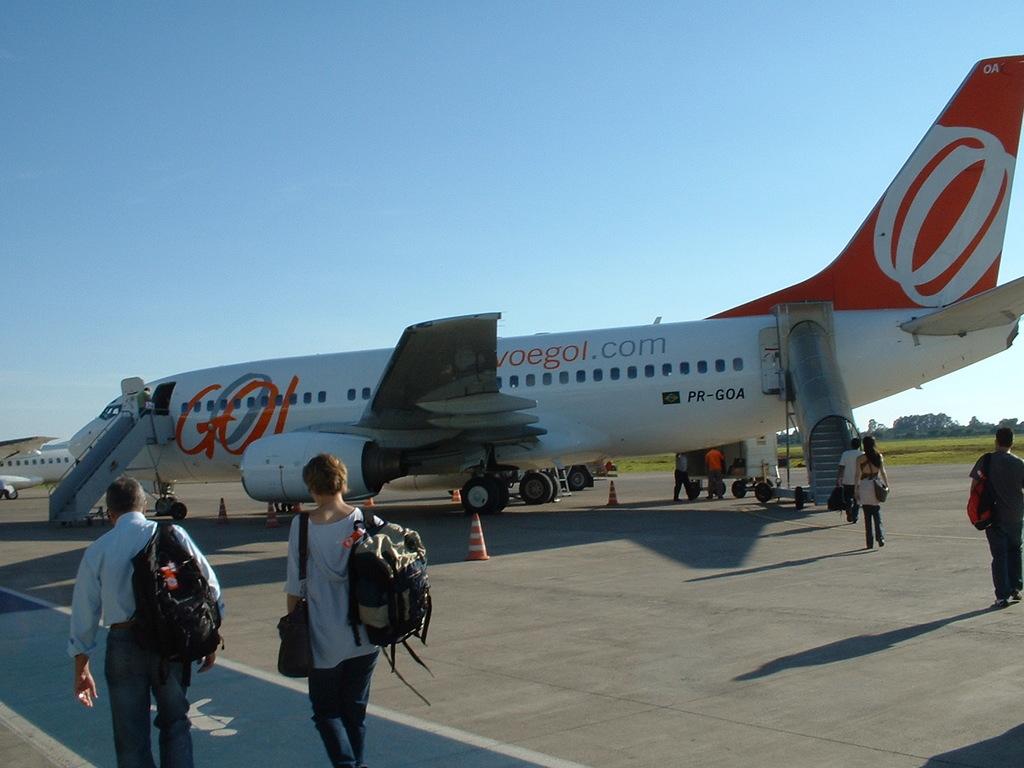What does it say on the front half of the plane?
Your response must be concise. Go. 